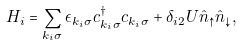Convert formula to latex. <formula><loc_0><loc_0><loc_500><loc_500>H _ { i } = \sum _ { k _ { i } \sigma } \epsilon _ { k _ { i } \sigma } c _ { k _ { i } \sigma } ^ { \dagger } c _ { k _ { i } \sigma } + \delta _ { i 2 } U \hat { n } _ { \uparrow } \hat { n } _ { \downarrow } ,</formula> 